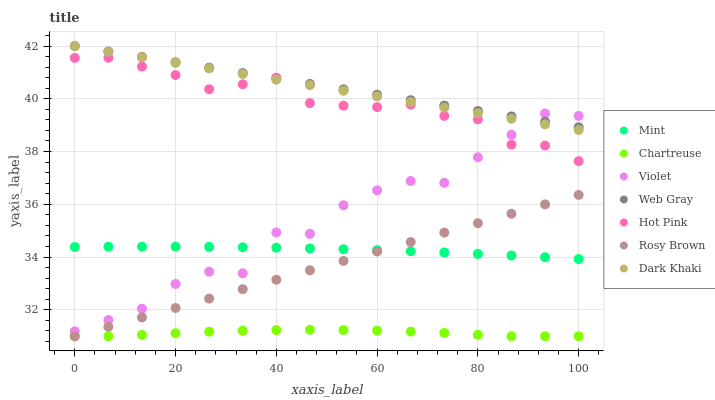Does Chartreuse have the minimum area under the curve?
Answer yes or no. Yes. Does Web Gray have the maximum area under the curve?
Answer yes or no. Yes. Does Hot Pink have the minimum area under the curve?
Answer yes or no. No. Does Hot Pink have the maximum area under the curve?
Answer yes or no. No. Is Web Gray the smoothest?
Answer yes or no. Yes. Is Violet the roughest?
Answer yes or no. Yes. Is Hot Pink the smoothest?
Answer yes or no. No. Is Hot Pink the roughest?
Answer yes or no. No. Does Chartreuse have the lowest value?
Answer yes or no. Yes. Does Hot Pink have the lowest value?
Answer yes or no. No. Does Dark Khaki have the highest value?
Answer yes or no. Yes. Does Hot Pink have the highest value?
Answer yes or no. No. Is Mint less than Web Gray?
Answer yes or no. Yes. Is Web Gray greater than Mint?
Answer yes or no. Yes. Does Hot Pink intersect Dark Khaki?
Answer yes or no. Yes. Is Hot Pink less than Dark Khaki?
Answer yes or no. No. Is Hot Pink greater than Dark Khaki?
Answer yes or no. No. Does Mint intersect Web Gray?
Answer yes or no. No. 